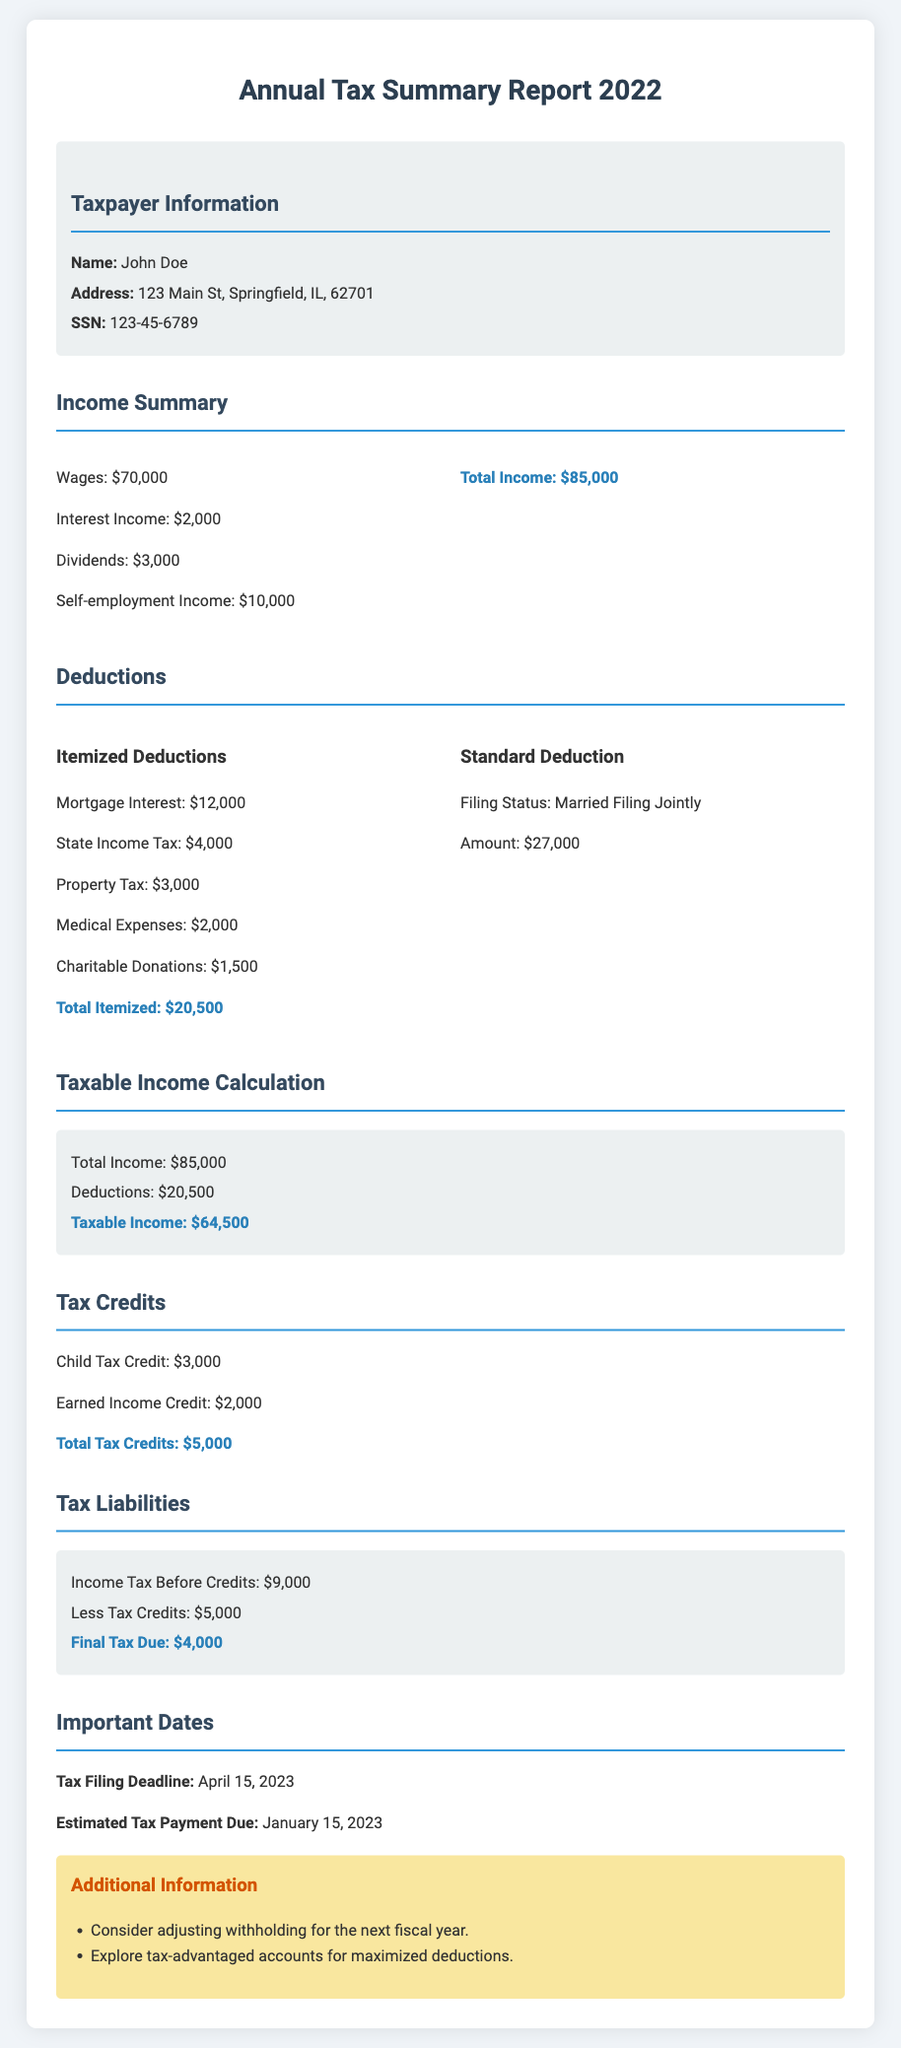What is the taxpayer's name? The document states the taxpayer's name in the Taxpayer Information section.
Answer: John Doe What is the total income? The total income is presented in the Income Summary section, calculated from various income sources.
Answer: $85,000 What is the amount of the standard deduction? The standard deduction amount is listed in the Deductions section under Standard Deduction.
Answer: $27,000 What is the final tax due? The final tax due is calculated in the Tax Liabilities section and presented after tax credits are deducted.
Answer: $4,000 What is the amount of the Child Tax Credit? The Child Tax Credit amount is specified in the Tax Credits section of the document.
Answer: $3,000 What is taxable income? Taxable income is determined by subtracting deductions from total income, and this is noted in the Taxable Income Calculation section.
Answer: $64,500 When is the tax filing deadline? The tax filing deadline is stated in the Important Dates section of the document.
Answer: April 15, 2023 How much were the itemized deductions? The total itemized deductions are summed in the Deductions section of the report.
Answer: $20,500 What is the amount of total tax credits? The total tax credits are listed in the Tax Credits section and calculated from various credits.
Answer: $5,000 